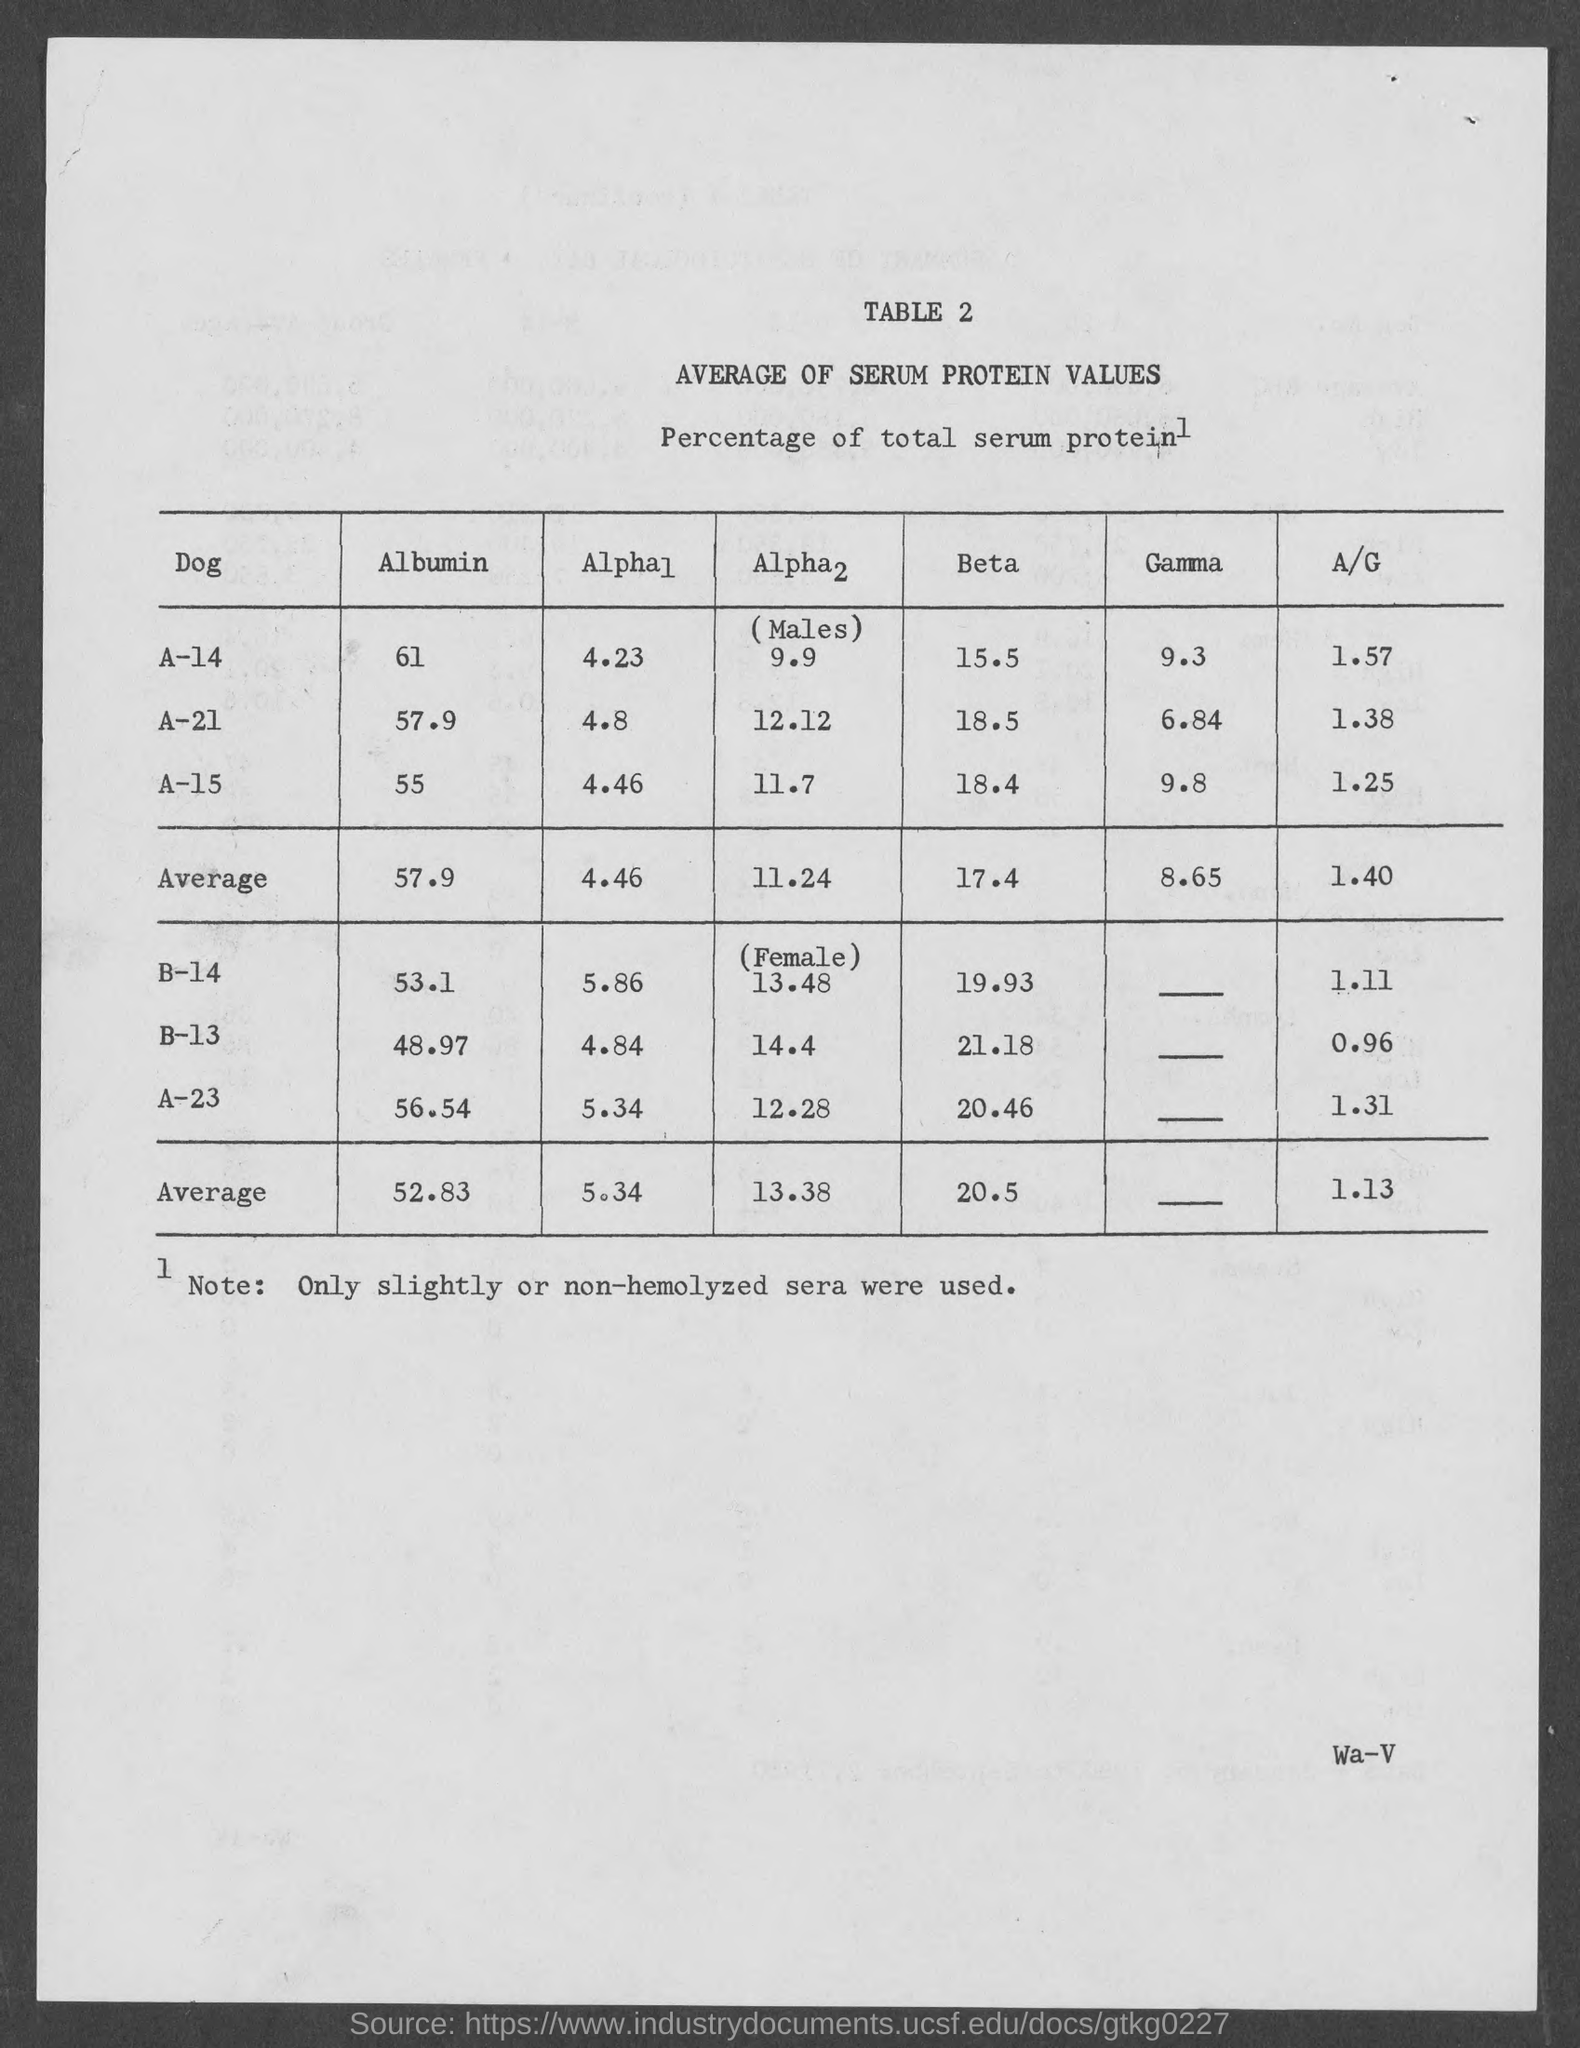What is the title of table 2?
Offer a very short reply. Average of Serum Protein Values. 